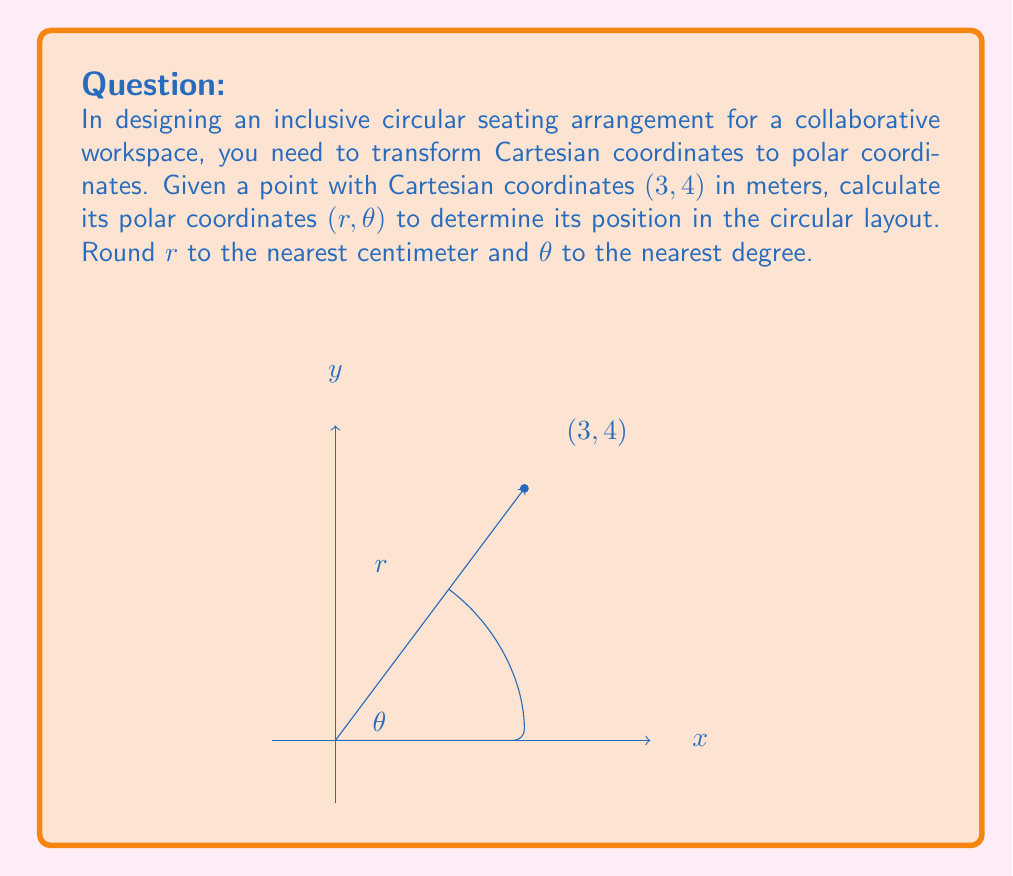Can you answer this question? To transform Cartesian coordinates (x, y) to polar coordinates (r, θ), we use the following formulas:

1. For r (distance from origin):
   $$r = \sqrt{x^2 + y^2}$$

2. For θ (angle from positive x-axis):
   $$\theta = \tan^{-1}\left(\frac{y}{x}\right)$$

Step 1: Calculate r
$$r = \sqrt{3^2 + 4^2} = \sqrt{9 + 16} = \sqrt{25} = 5\text{ m}$$

Step 2: Calculate θ
$$\theta = \tan^{-1}\left(\frac{4}{3}\right) \approx 0.9272952180\text{ radians}$$

Step 3: Convert θ to degrees
$$\theta \text{ in degrees} = 0.9272952180 \times \frac{180°}{\pi} \approx 53.13010235°$$

Step 4: Round r to the nearest centimeter
5 m = 500 cm (no rounding needed)

Step 5: Round θ to the nearest degree
53.13010235° ≈ 53°

Therefore, the polar coordinates are (500 cm, 53°).
Answer: (500 cm, 53°) 